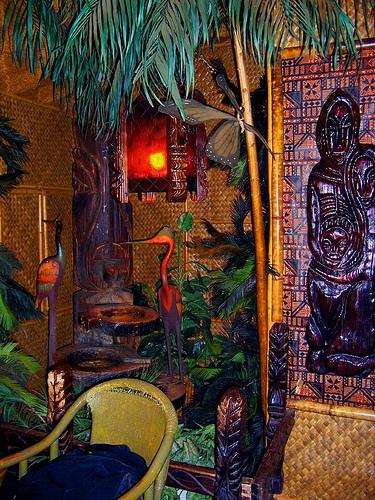Would there be a chair in the image if the chair was not in the picture? No 